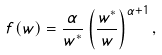<formula> <loc_0><loc_0><loc_500><loc_500>f ( w ) = \frac { \alpha } { w ^ { * } } \left ( \frac { w ^ { * } } { w } \right ) ^ { \alpha + 1 } ,</formula> 